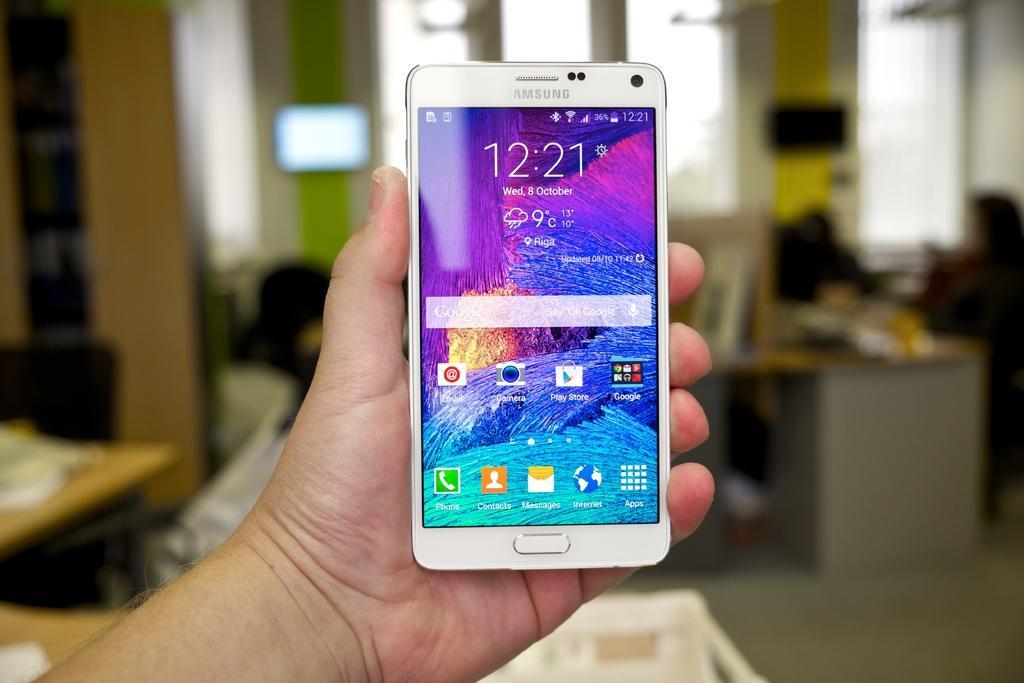Please provide a concise description of this image. In this image I can see there is a person holding a smartphone and there are a few icons on the screen. The background of the image is blurred. 